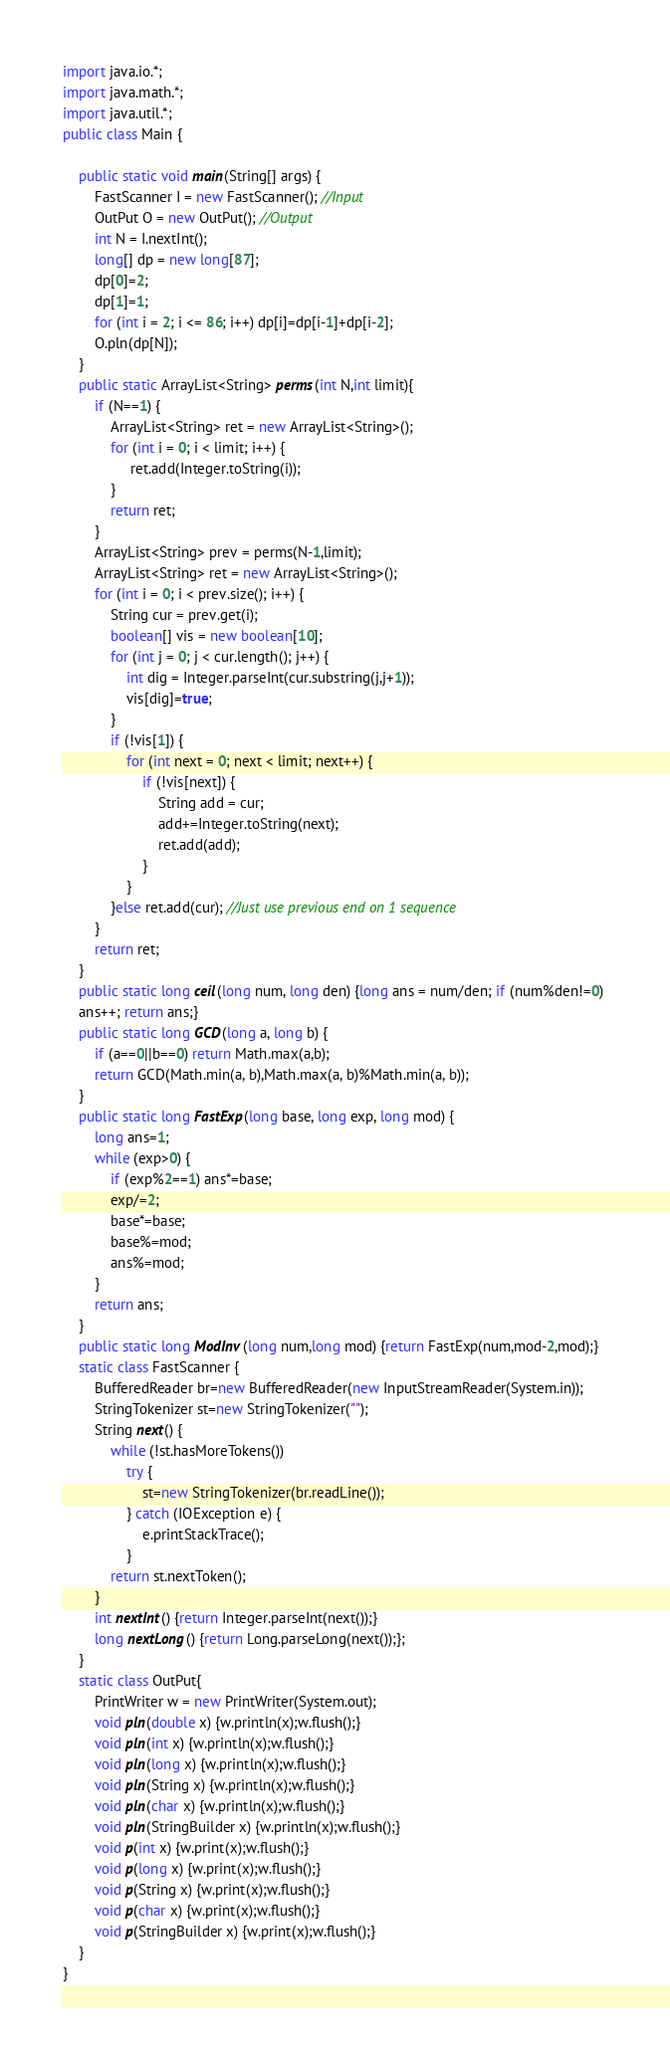Convert code to text. <code><loc_0><loc_0><loc_500><loc_500><_Java_>import java.io.*;
import java.math.*;
import java.util.*;
public class Main { 
 
	public static void main(String[] args) { 
		FastScanner I = new FastScanner(); //Input
		OutPut O = new OutPut(); //Output
		int N = I.nextInt();
		long[] dp = new long[87];
		dp[0]=2;
		dp[1]=1;
		for (int i = 2; i <= 86; i++) dp[i]=dp[i-1]+dp[i-2];
		O.pln(dp[N]);
	}
	public static ArrayList<String> perms(int N,int limit){
		if (N==1) {
			ArrayList<String> ret = new ArrayList<String>();
			for (int i = 0; i < limit; i++) {
				 ret.add(Integer.toString(i));
			}
			return ret;
		}
		ArrayList<String> prev = perms(N-1,limit);
		ArrayList<String> ret = new ArrayList<String>();
		for (int i = 0; i < prev.size(); i++) {
			String cur = prev.get(i);
			boolean[] vis = new boolean[10];
			for (int j = 0; j < cur.length(); j++) {
				int dig = Integer.parseInt(cur.substring(j,j+1));
				vis[dig]=true;
			}
			if (!vis[1]) {
				for (int next = 0; next < limit; next++) {
					if (!vis[next]) {
						String add = cur;
						add+=Integer.toString(next);
						ret.add(add);
					}
				}
			}else ret.add(cur); //Just use previous end on 1 sequence	
		}
		return ret;
	}
	public static long ceil(long num, long den) {long ans = num/den; if (num%den!=0) 
	ans++; return ans;}
	public static long GCD(long a, long b) {
		if (a==0||b==0) return Math.max(a,b);
		return GCD(Math.min(a, b),Math.max(a, b)%Math.min(a, b));
	}
	public static long FastExp(long base, long exp, long mod) {
		long ans=1;
		while (exp>0) {
			if (exp%2==1) ans*=base;
			exp/=2;
			base*=base;
			base%=mod;
			ans%=mod;
		}
		return ans;
	}
	public static long ModInv(long num,long mod) {return FastExp(num,mod-2,mod);}
	static class FastScanner {
		BufferedReader br=new BufferedReader(new InputStreamReader(System.in));
		StringTokenizer st=new StringTokenizer("");
		String next() {
			while (!st.hasMoreTokens())
				try {
					st=new StringTokenizer(br.readLine());
				} catch (IOException e) {
					e.printStackTrace();
				}
			return st.nextToken();
		}
		int nextInt() {return Integer.parseInt(next());}
		long nextLong() {return Long.parseLong(next());};
	}
	static class OutPut{
		PrintWriter w = new PrintWriter(System.out);
		void pln(double x) {w.println(x);w.flush();}
		void pln(int x) {w.println(x);w.flush();}
		void pln(long x) {w.println(x);w.flush();}
		void pln(String x) {w.println(x);w.flush();}
		void pln(char x) {w.println(x);w.flush();}
		void pln(StringBuilder x) {w.println(x);w.flush();}
		void p(int x) {w.print(x);w.flush();}
		void p(long x) {w.print(x);w.flush();}
		void p(String x) {w.print(x);w.flush();}
		void p(char x) {w.print(x);w.flush();}
		void p(StringBuilder x) {w.print(x);w.flush();}
	}
}
</code> 